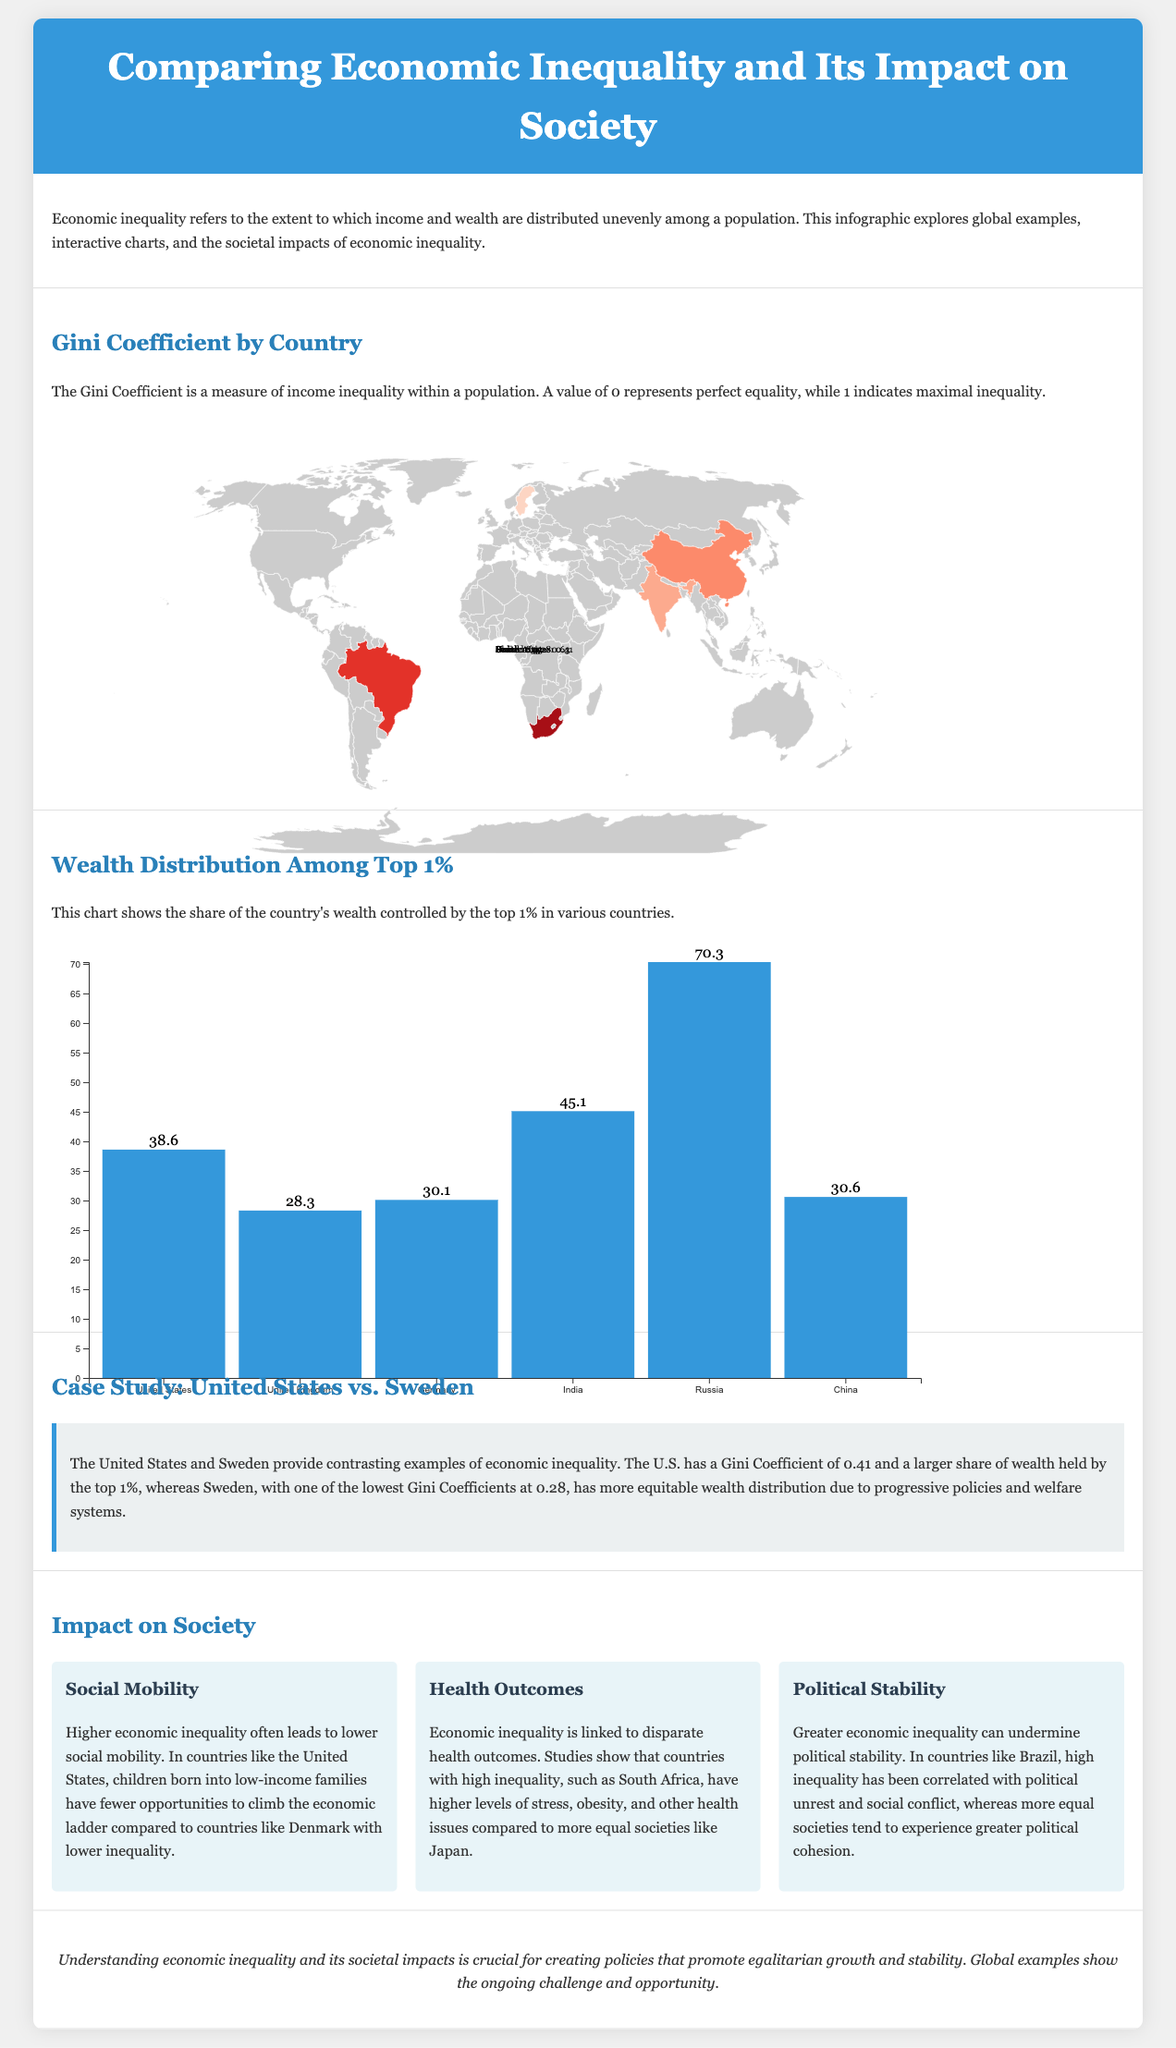What is the Gini Coefficient for the United States? The Gini Coefficient for the United States is 0.41 as stated in the case study section.
Answer: 0.41 Which country has the lowest Gini Coefficient mentioned? The case study mentions Sweden as having a Gini Coefficient of 0.28, which is the lowest.
Answer: Sweden What percentage of wealth does the top 1% control in the United States? The wealth distribution chart shows that the top 1% controls 38.6% of wealth in the United States.
Answer: 38.6% Which health issue is associated with high economic inequality in countries like South Africa? The document describes higher levels of stress and obesity associated with economic inequality in countries like South Africa.
Answer: Stress, obesity What is one impact of higher economic inequality on social mobility? It is mentioned that higher economic inequality often leads to lower social mobility, particularly in the United States.
Answer: Lower social mobility Which country is compared with the United States in terms of economic inequality? Sweden is used as a contrasting example to the United States regarding economic inequality.
Answer: Sweden What is the color scale used for in the world map? The color scale on the world map is a sequential scale that indicates levels of economic inequality, with a domain of 0.2 to 0.7.
Answer: Economic inequality levels How many countries are illustrated in the bar chart? The bar chart includes wealth distribution data for six countries.
Answer: Six countries 